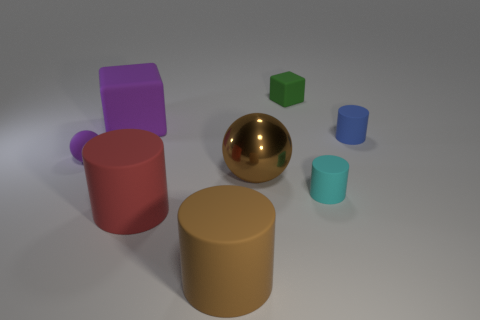Is there a cyan matte object of the same shape as the tiny green rubber object?
Offer a terse response. No. What is the shape of the purple thing behind the small purple rubber sphere?
Offer a very short reply. Cube. There is a big rubber object behind the tiny cyan matte thing behind the red cylinder; how many rubber objects are in front of it?
Offer a terse response. 5. There is a matte thing that is on the left side of the purple cube; is its color the same as the large cube?
Make the answer very short. Yes. What number of other objects are the same shape as the red object?
Keep it short and to the point. 3. What number of other objects are the same material as the purple block?
Provide a short and direct response. 6. What is the material of the tiny cylinder in front of the purple rubber object that is in front of the matte cylinder behind the metal ball?
Provide a succinct answer. Rubber. Do the brown sphere and the purple cube have the same material?
Keep it short and to the point. No. How many balls are either large rubber objects or small cyan objects?
Your response must be concise. 0. There is a small thing that is left of the big purple rubber object; what color is it?
Offer a terse response. Purple. 